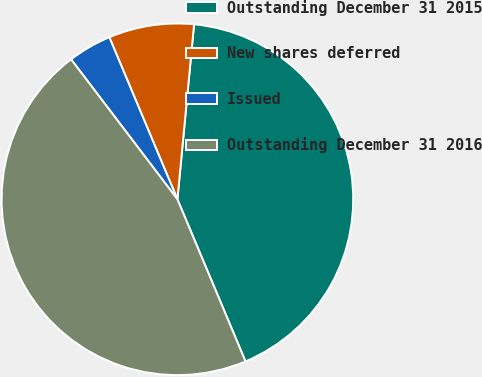<chart> <loc_0><loc_0><loc_500><loc_500><pie_chart><fcel>Outstanding December 31 2015<fcel>New shares deferred<fcel>Issued<fcel>Outstanding December 31 2016<nl><fcel>42.16%<fcel>7.84%<fcel>4.01%<fcel>45.99%<nl></chart> 